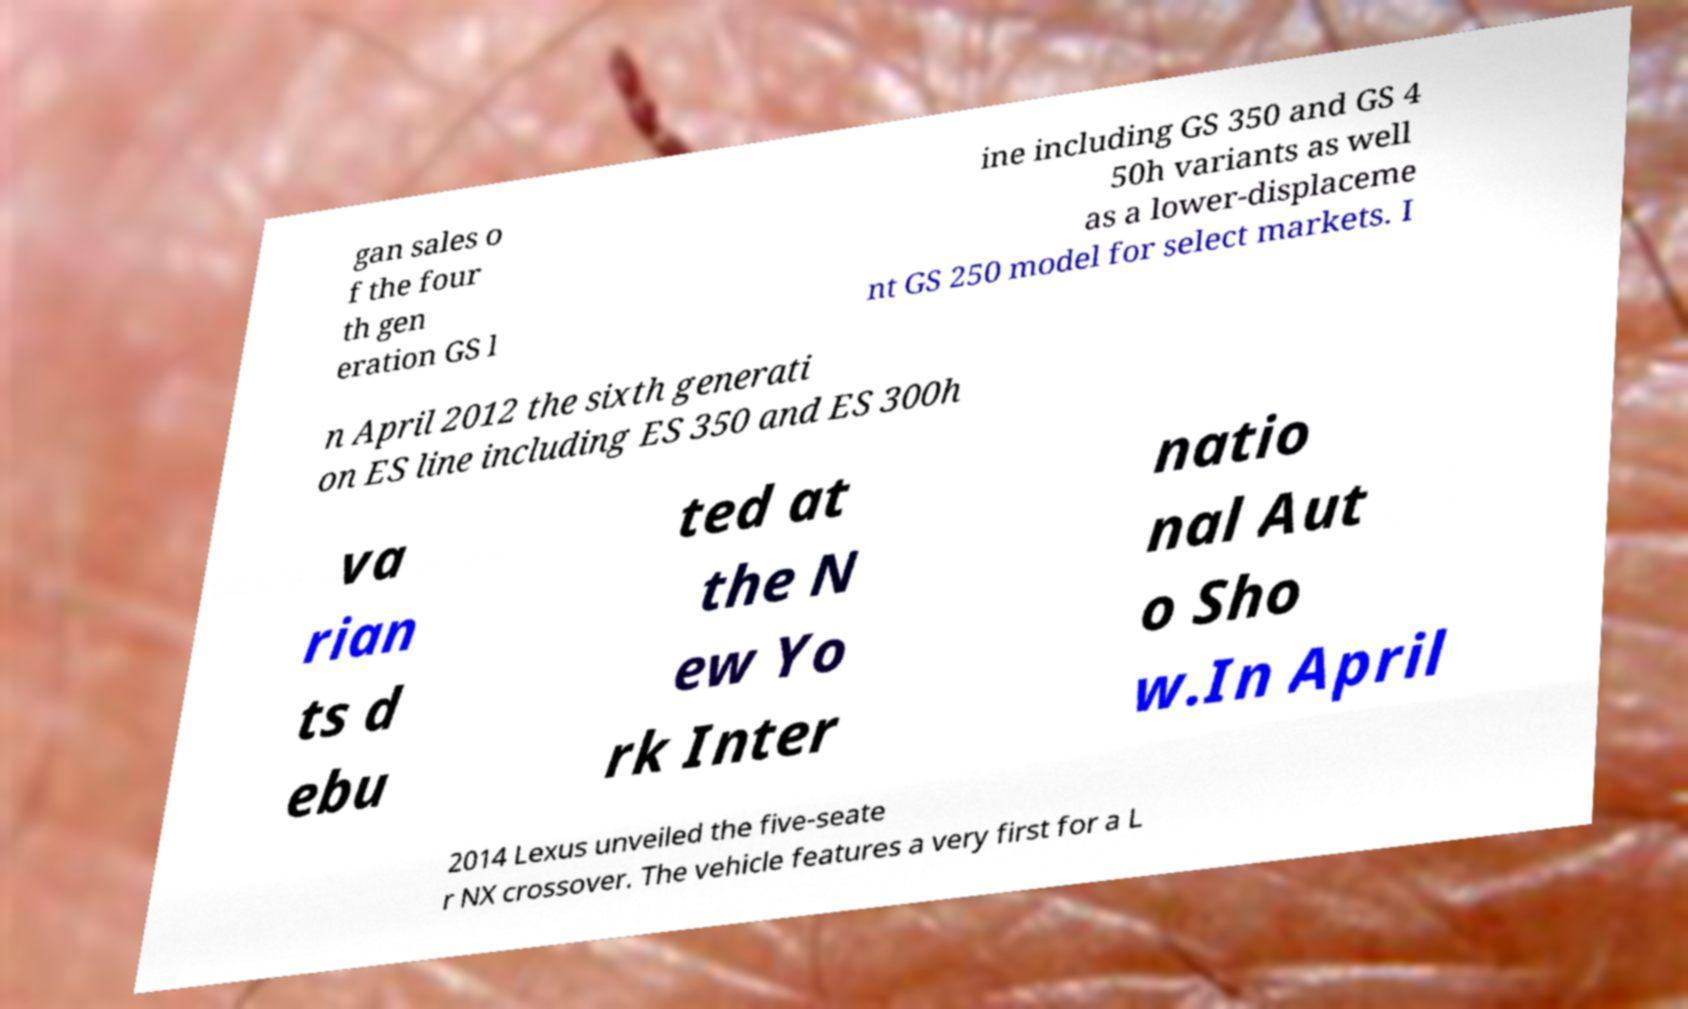I need the written content from this picture converted into text. Can you do that? gan sales o f the four th gen eration GS l ine including GS 350 and GS 4 50h variants as well as a lower-displaceme nt GS 250 model for select markets. I n April 2012 the sixth generati on ES line including ES 350 and ES 300h va rian ts d ebu ted at the N ew Yo rk Inter natio nal Aut o Sho w.In April 2014 Lexus unveiled the five-seate r NX crossover. The vehicle features a very first for a L 